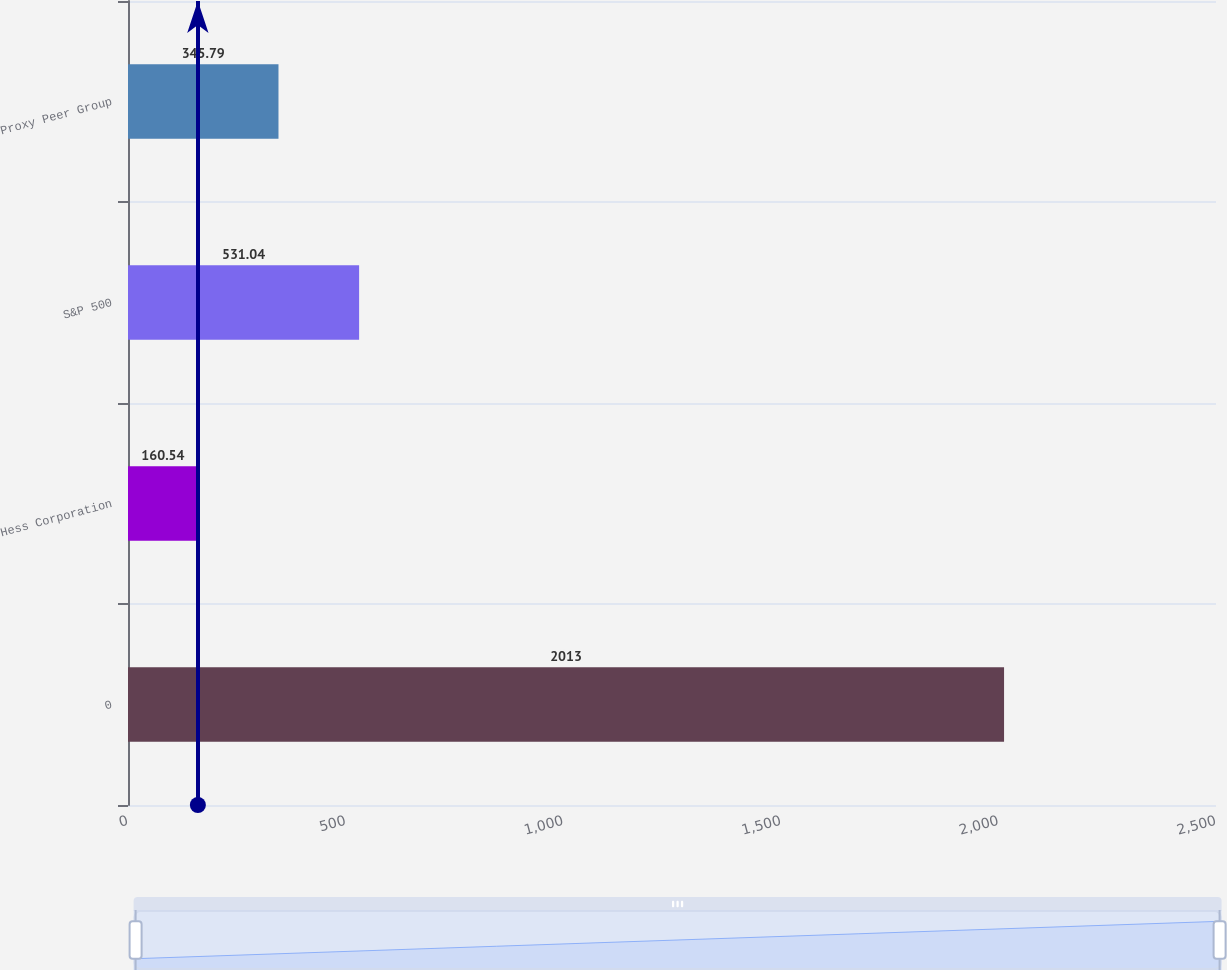Convert chart. <chart><loc_0><loc_0><loc_500><loc_500><bar_chart><fcel>0<fcel>Hess Corporation<fcel>S&P 500<fcel>Proxy Peer Group<nl><fcel>2013<fcel>160.54<fcel>531.04<fcel>345.79<nl></chart> 